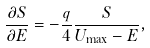Convert formula to latex. <formula><loc_0><loc_0><loc_500><loc_500>\frac { \partial S } { \partial E } & = - \frac { q } { 4 } \frac { S } { U _ { \max } - E } ,</formula> 